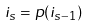<formula> <loc_0><loc_0><loc_500><loc_500>i _ { s } = p ( i _ { s - 1 } )</formula> 